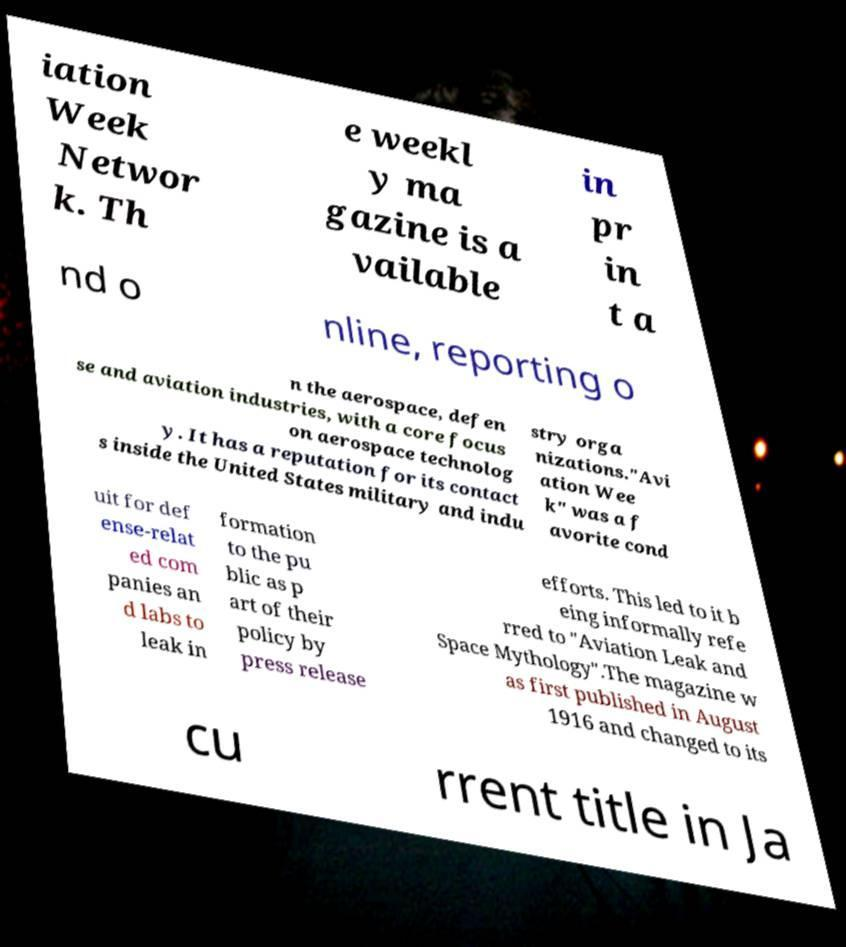Could you assist in decoding the text presented in this image and type it out clearly? iation Week Networ k. Th e weekl y ma gazine is a vailable in pr in t a nd o nline, reporting o n the aerospace, defen se and aviation industries, with a core focus on aerospace technolog y. It has a reputation for its contact s inside the United States military and indu stry orga nizations."Avi ation Wee k" was a f avorite cond uit for def ense-relat ed com panies an d labs to leak in formation to the pu blic as p art of their policy by press release efforts. This led to it b eing informally refe rred to "Aviation Leak and Space Mythology".The magazine w as first published in August 1916 and changed to its cu rrent title in Ja 